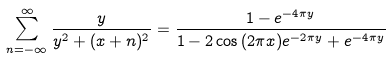Convert formula to latex. <formula><loc_0><loc_0><loc_500><loc_500>\sum _ { n = - \infty } ^ { \infty } \frac { y } { y ^ { 2 } + ( x + n ) ^ { 2 } } = \frac { 1 - e ^ { - 4 \pi y } } { 1 - 2 \cos { ( 2 \pi x ) } e ^ { - 2 \pi y } + e ^ { - 4 \pi y } }</formula> 